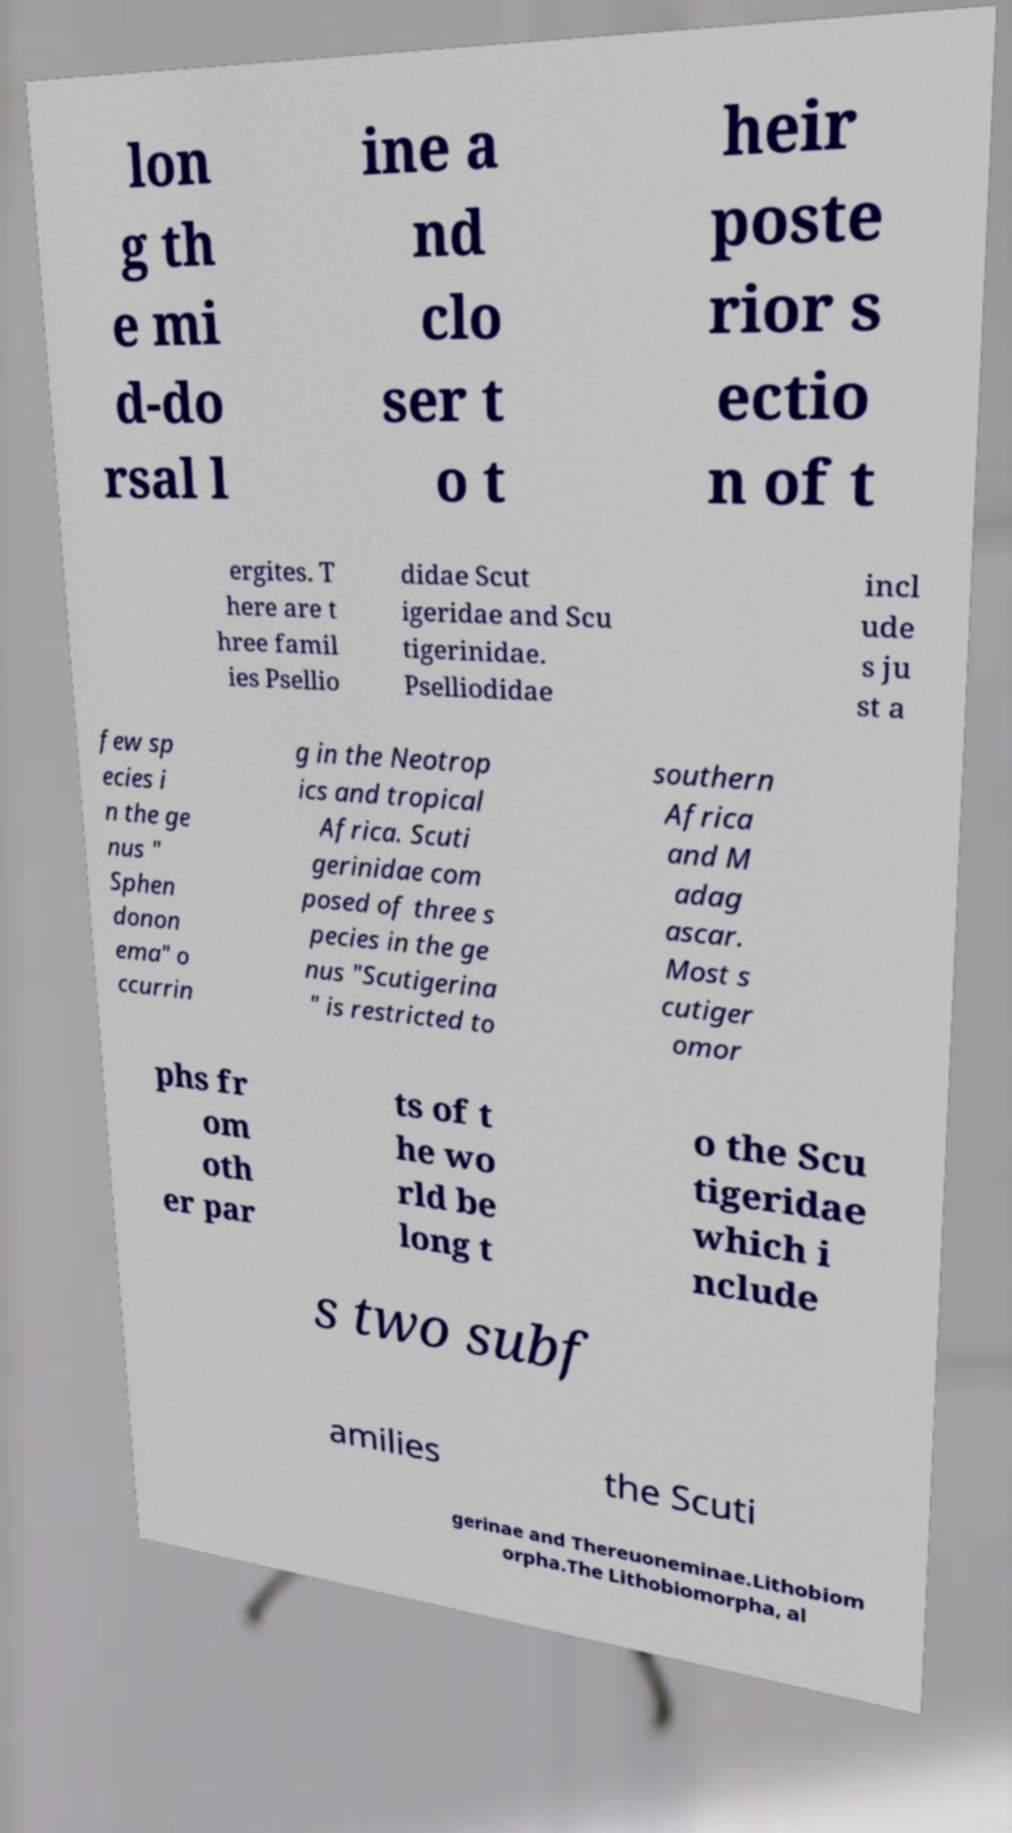For documentation purposes, I need the text within this image transcribed. Could you provide that? lon g th e mi d-do rsal l ine a nd clo ser t o t heir poste rior s ectio n of t ergites. T here are t hree famil ies Psellio didae Scut igeridae and Scu tigerinidae. Pselliodidae incl ude s ju st a few sp ecies i n the ge nus " Sphen donon ema" o ccurrin g in the Neotrop ics and tropical Africa. Scuti gerinidae com posed of three s pecies in the ge nus "Scutigerina " is restricted to southern Africa and M adag ascar. Most s cutiger omor phs fr om oth er par ts of t he wo rld be long t o the Scu tigeridae which i nclude s two subf amilies the Scuti gerinae and Thereuoneminae.Lithobiom orpha.The Lithobiomorpha, al 